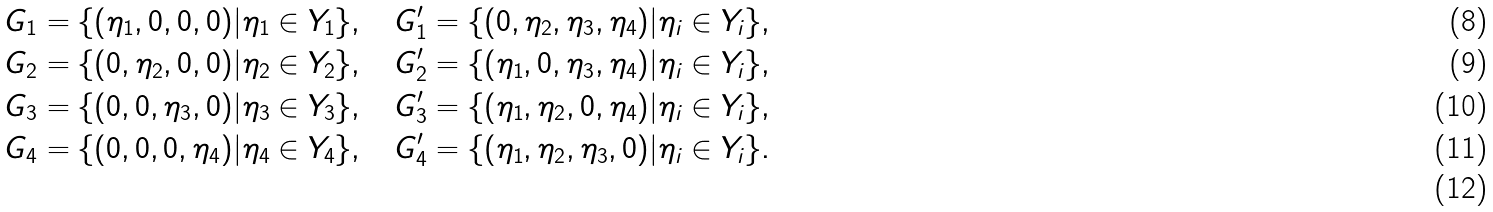Convert formula to latex. <formula><loc_0><loc_0><loc_500><loc_500>& G _ { 1 } = \{ ( \eta _ { 1 } , 0 , 0 , 0 ) | \eta _ { 1 } \in Y _ { 1 } \} , \quad G ^ { \prime } _ { 1 } = \{ ( 0 , \eta _ { 2 } , \eta _ { 3 } , \eta _ { 4 } ) | \eta _ { i } \in Y _ { i } \} , \\ & G _ { 2 } = \{ ( 0 , \eta _ { 2 } , 0 , 0 ) | \eta _ { 2 } \in Y _ { 2 } \} , \quad G ^ { \prime } _ { 2 } = \{ ( \eta _ { 1 } , 0 , \eta _ { 3 } , \eta _ { 4 } ) | \eta _ { i } \in Y _ { i } \} , \\ & G _ { 3 } = \{ ( 0 , 0 , \eta _ { 3 } , 0 ) | \eta _ { 3 } \in Y _ { 3 } \} , \quad G ^ { \prime } _ { 3 } = \{ ( \eta _ { 1 } , \eta _ { 2 } , 0 , \eta _ { 4 } ) | \eta _ { i } \in Y _ { i } \} , \\ & G _ { 4 } = \{ ( 0 , 0 , 0 , \eta _ { 4 } ) | \eta _ { 4 } \in Y _ { 4 } \} , \quad G ^ { \prime } _ { 4 } = \{ ( \eta _ { 1 } , \eta _ { 2 } , \eta _ { 3 } , 0 ) | \eta _ { i } \in Y _ { i } \} . \\</formula> 